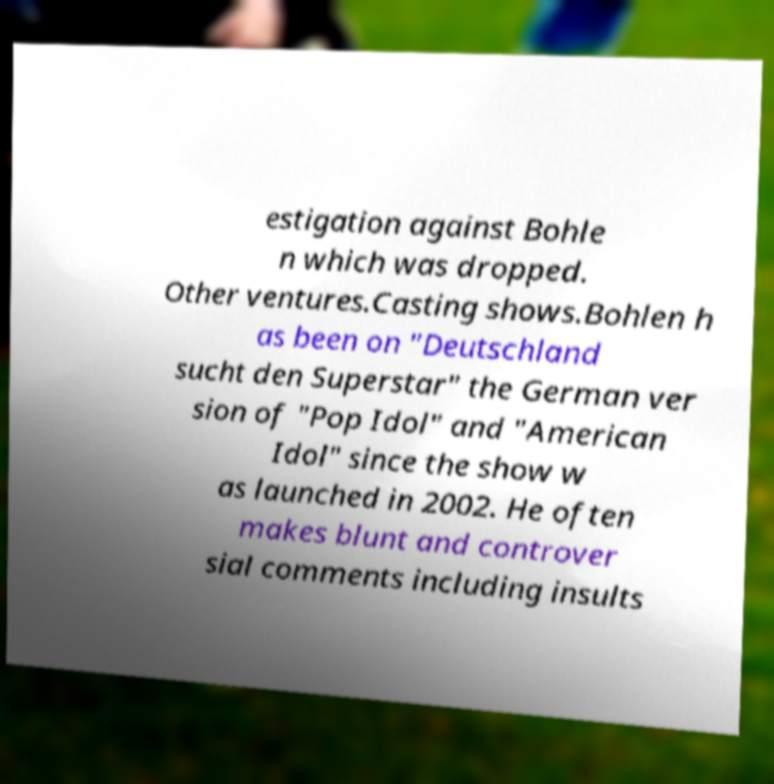I need the written content from this picture converted into text. Can you do that? estigation against Bohle n which was dropped. Other ventures.Casting shows.Bohlen h as been on "Deutschland sucht den Superstar" the German ver sion of "Pop Idol" and "American Idol" since the show w as launched in 2002. He often makes blunt and controver sial comments including insults 